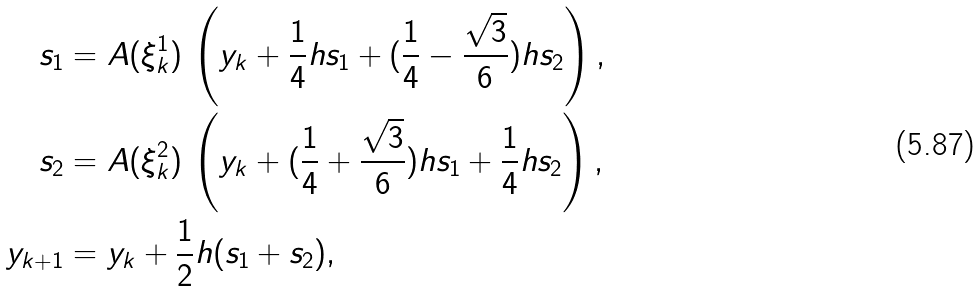Convert formula to latex. <formula><loc_0><loc_0><loc_500><loc_500>s _ { 1 } & = A ( \xi _ { k } ^ { 1 } ) \, \left ( y _ { k } + \frac { 1 } { 4 } h s _ { 1 } + ( \frac { 1 } { 4 } - \frac { \sqrt { 3 } } 6 ) h s _ { 2 } \right ) , \\ s _ { 2 } & = A ( \xi _ { k } ^ { 2 } ) \, \left ( y _ { k } + ( \frac { 1 } { 4 } + \frac { \sqrt { 3 } } 6 ) h s _ { 1 } + \frac { 1 } { 4 } h s _ { 2 } \right ) , \\ y _ { k + 1 } & = y _ { k } + \frac { 1 } { 2 } h ( s _ { 1 } + s _ { 2 } ) ,</formula> 